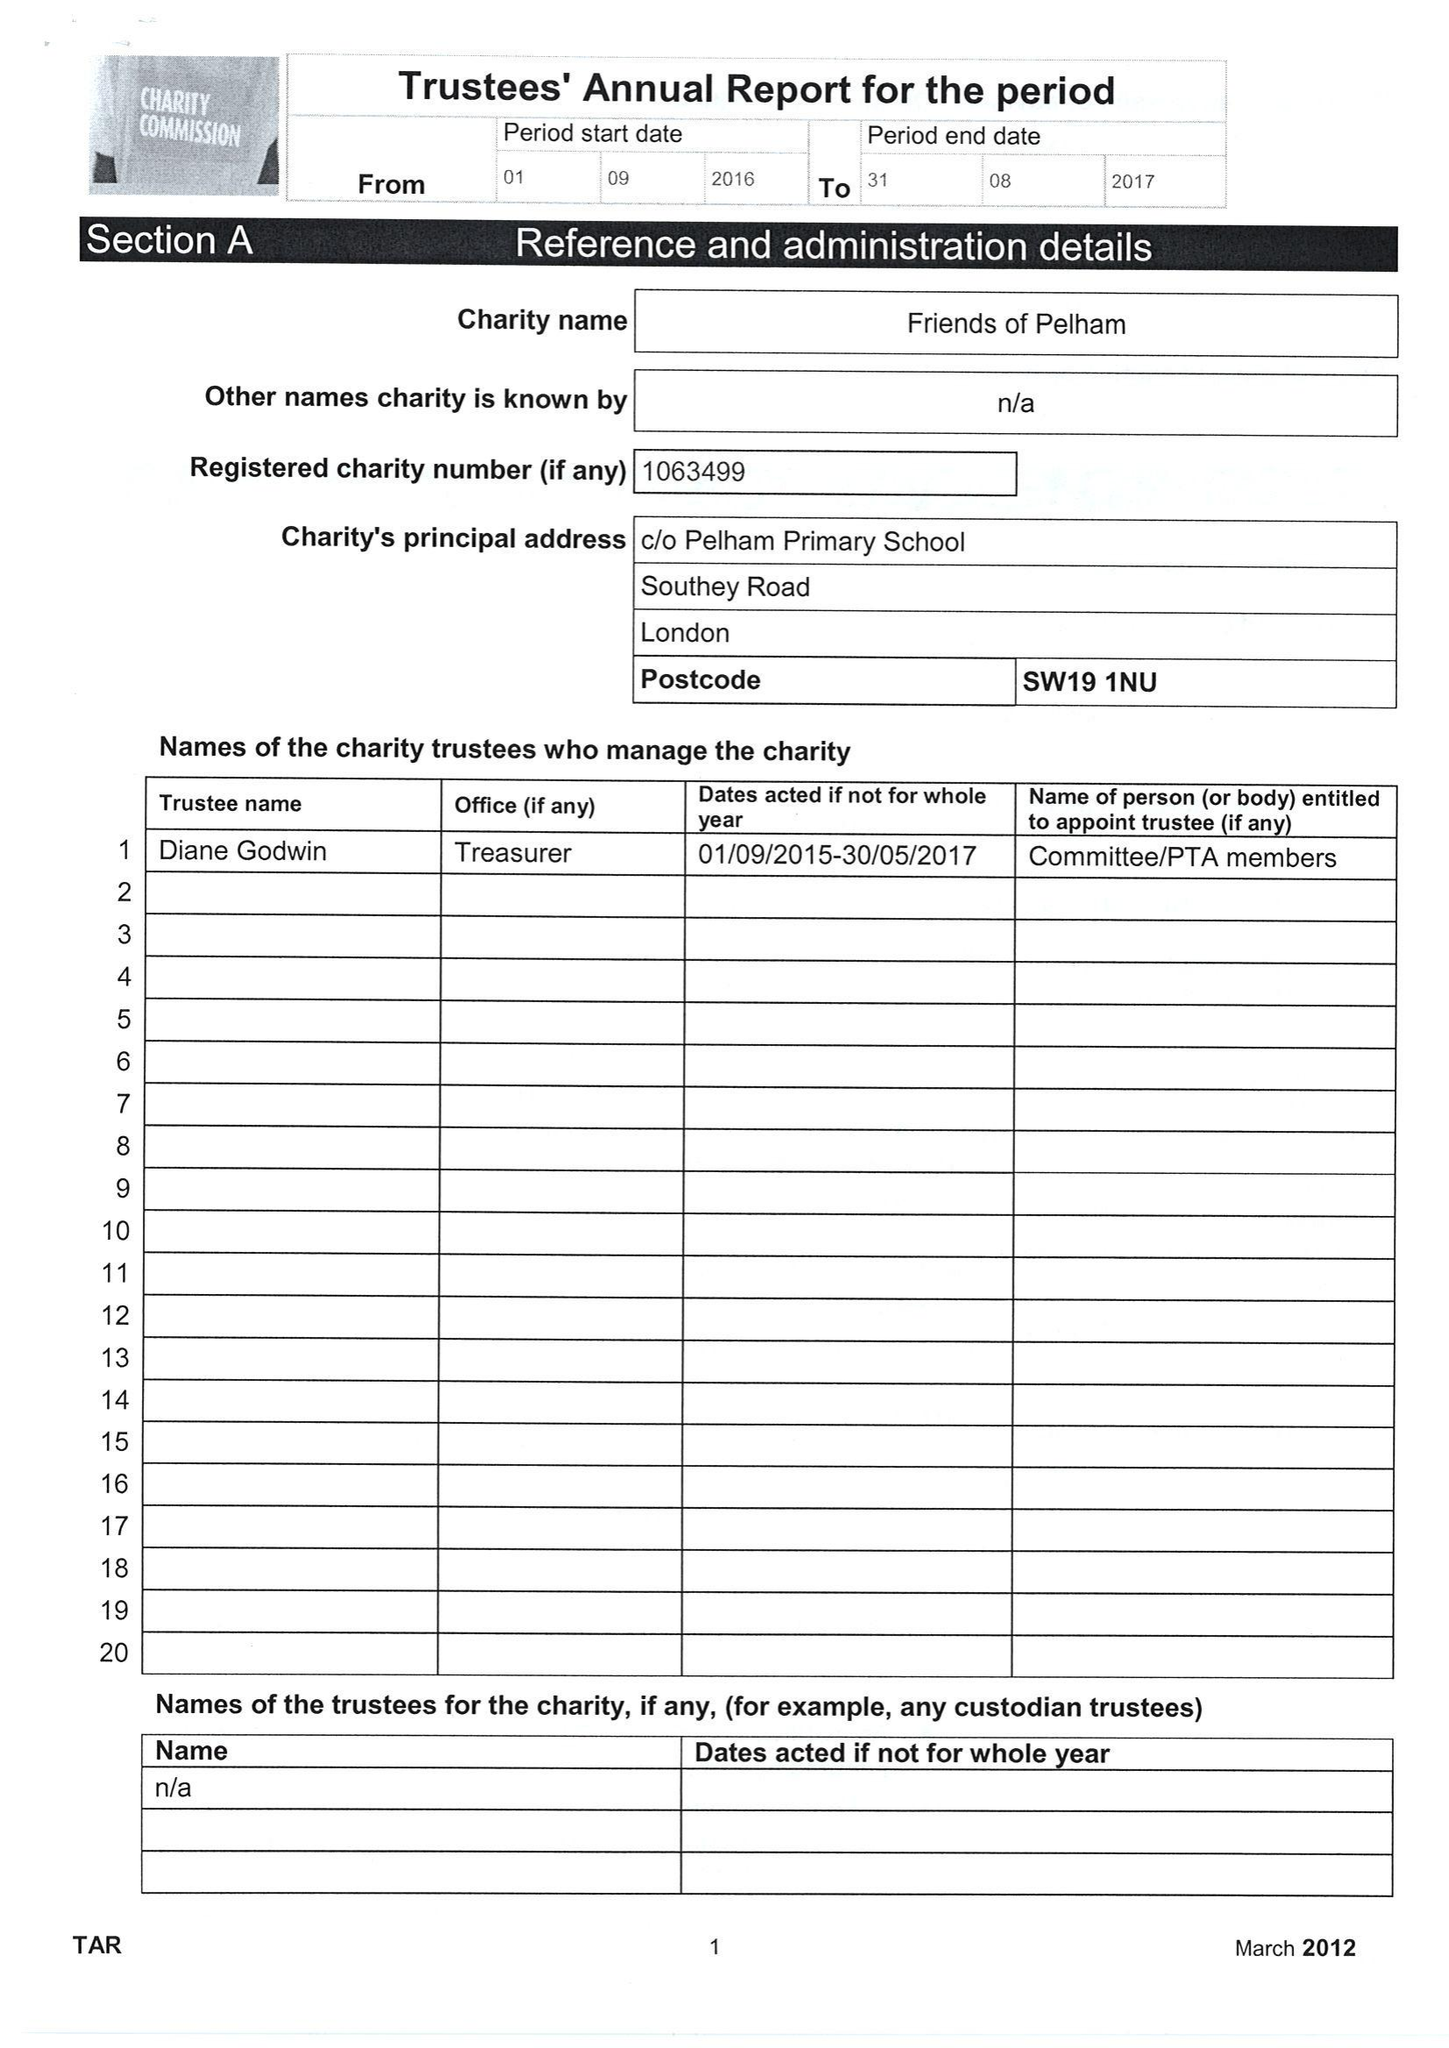What is the value for the address__postcode?
Answer the question using a single word or phrase. SW19 1NU 